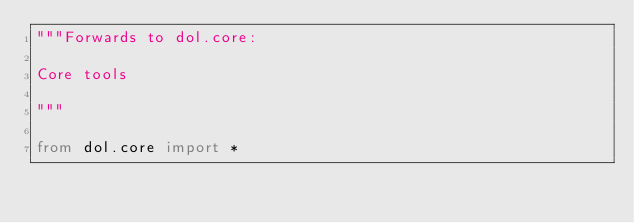<code> <loc_0><loc_0><loc_500><loc_500><_Python_>"""Forwards to dol.core:

Core tools

"""

from dol.core import *
</code> 